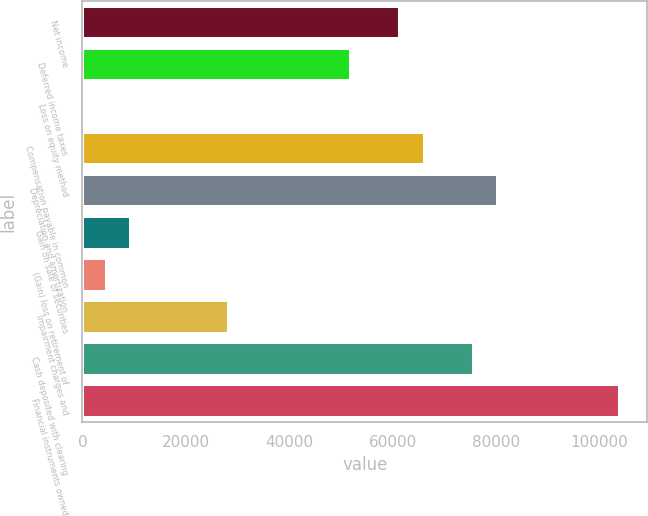Convert chart to OTSL. <chart><loc_0><loc_0><loc_500><loc_500><bar_chart><fcel>Net income<fcel>Deferred income taxes<fcel>Loss on equity method<fcel>Compensation payable in common<fcel>Depreciation and amortization<fcel>Gain on sale of securities<fcel>(Gain) loss on retirement of<fcel>Impairment charges and<fcel>Cash deposited with clearing<fcel>Financial instruments owned<nl><fcel>61498.7<fcel>52040.9<fcel>23<fcel>66227.6<fcel>80414.3<fcel>9480.8<fcel>4751.9<fcel>28396.4<fcel>75685.4<fcel>104059<nl></chart> 